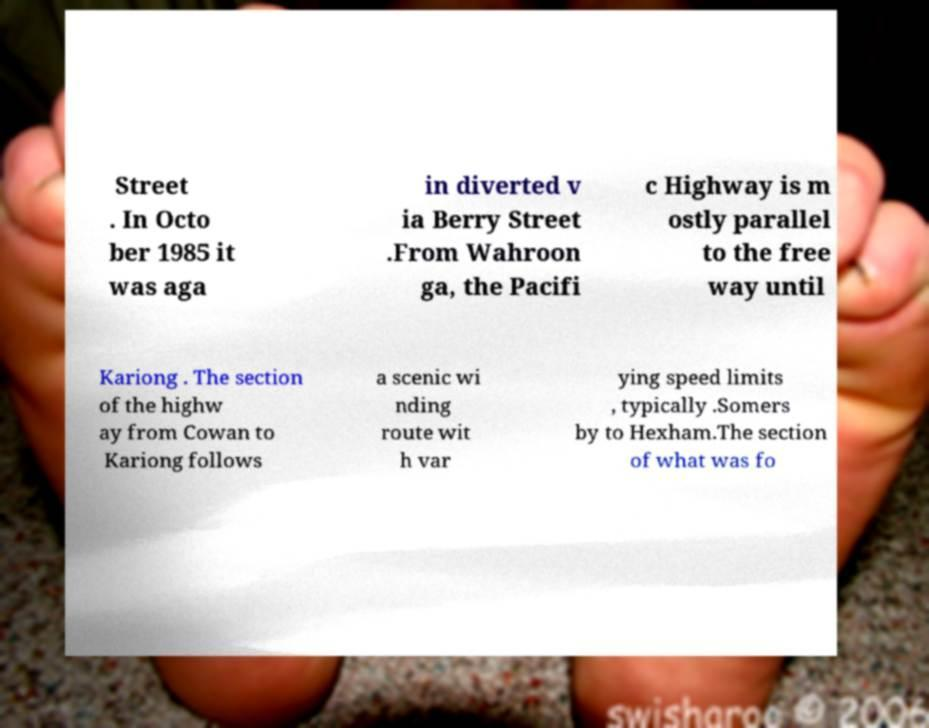Please read and relay the text visible in this image. What does it say? Street . In Octo ber 1985 it was aga in diverted v ia Berry Street .From Wahroon ga, the Pacifi c Highway is m ostly parallel to the free way until Kariong . The section of the highw ay from Cowan to Kariong follows a scenic wi nding route wit h var ying speed limits , typically .Somers by to Hexham.The section of what was fo 